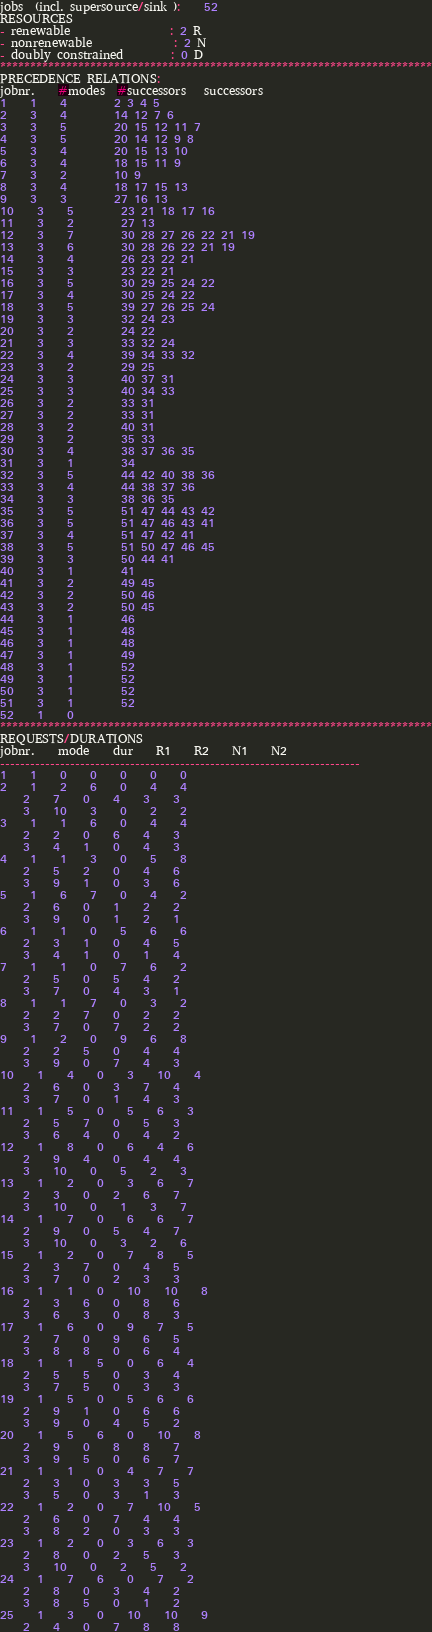Convert code to text. <code><loc_0><loc_0><loc_500><loc_500><_ObjectiveC_>jobs  (incl. supersource/sink ):	52
RESOURCES
- renewable                 : 2 R
- nonrenewable              : 2 N
- doubly constrained        : 0 D
************************************************************************
PRECEDENCE RELATIONS:
jobnr.    #modes  #successors   successors
1	1	4		2 3 4 5 
2	3	4		14 12 7 6 
3	3	5		20 15 12 11 7 
4	3	5		20 14 12 9 8 
5	3	4		20 15 13 10 
6	3	4		18 15 11 9 
7	3	2		10 9 
8	3	4		18 17 15 13 
9	3	3		27 16 13 
10	3	5		23 21 18 17 16 
11	3	2		27 13 
12	3	7		30 28 27 26 22 21 19 
13	3	6		30 28 26 22 21 19 
14	3	4		26 23 22 21 
15	3	3		23 22 21 
16	3	5		30 29 25 24 22 
17	3	4		30 25 24 22 
18	3	5		39 27 26 25 24 
19	3	3		32 24 23 
20	3	2		24 22 
21	3	3		33 32 24 
22	3	4		39 34 33 32 
23	3	2		29 25 
24	3	3		40 37 31 
25	3	3		40 34 33 
26	3	2		33 31 
27	3	2		33 31 
28	3	2		40 31 
29	3	2		35 33 
30	3	4		38 37 36 35 
31	3	1		34 
32	3	5		44 42 40 38 36 
33	3	4		44 38 37 36 
34	3	3		38 36 35 
35	3	5		51 47 44 43 42 
36	3	5		51 47 46 43 41 
37	3	4		51 47 42 41 
38	3	5		51 50 47 46 45 
39	3	3		50 44 41 
40	3	1		41 
41	3	2		49 45 
42	3	2		50 46 
43	3	2		50 45 
44	3	1		46 
45	3	1		48 
46	3	1		48 
47	3	1		49 
48	3	1		52 
49	3	1		52 
50	3	1		52 
51	3	1		52 
52	1	0		
************************************************************************
REQUESTS/DURATIONS
jobnr.	mode	dur	R1	R2	N1	N2	
------------------------------------------------------------------------
1	1	0	0	0	0	0	
2	1	2	6	0	4	4	
	2	7	0	4	3	3	
	3	10	3	0	2	2	
3	1	1	6	0	4	4	
	2	2	0	6	4	3	
	3	4	1	0	4	3	
4	1	1	3	0	5	8	
	2	5	2	0	4	6	
	3	9	1	0	3	6	
5	1	6	7	0	4	2	
	2	6	0	1	2	2	
	3	9	0	1	2	1	
6	1	1	0	5	6	6	
	2	3	1	0	4	5	
	3	4	1	0	1	4	
7	1	1	0	7	6	2	
	2	5	0	5	4	2	
	3	7	0	4	3	1	
8	1	1	7	0	3	2	
	2	2	7	0	2	2	
	3	7	0	7	2	2	
9	1	2	0	9	6	8	
	2	2	5	0	4	4	
	3	9	0	7	4	3	
10	1	4	0	3	10	4	
	2	6	0	3	7	4	
	3	7	0	1	4	3	
11	1	5	0	5	6	3	
	2	5	7	0	5	3	
	3	6	4	0	4	2	
12	1	8	0	6	4	6	
	2	9	4	0	4	4	
	3	10	0	5	2	3	
13	1	2	0	3	6	7	
	2	3	0	2	6	7	
	3	10	0	1	3	7	
14	1	7	0	6	6	7	
	2	9	0	5	4	7	
	3	10	0	3	2	6	
15	1	2	0	7	8	5	
	2	3	7	0	4	5	
	3	7	0	2	3	3	
16	1	1	0	10	10	8	
	2	3	6	0	8	6	
	3	6	3	0	8	3	
17	1	6	0	9	7	5	
	2	7	0	9	6	5	
	3	8	8	0	6	4	
18	1	1	5	0	6	4	
	2	5	5	0	3	4	
	3	7	5	0	3	3	
19	1	5	0	5	6	6	
	2	9	1	0	6	6	
	3	9	0	4	5	2	
20	1	5	6	0	10	8	
	2	9	0	8	8	7	
	3	9	5	0	6	7	
21	1	1	0	4	7	7	
	2	3	0	3	3	5	
	3	5	0	3	1	3	
22	1	2	0	7	10	5	
	2	6	0	7	4	4	
	3	8	2	0	3	3	
23	1	2	0	3	6	3	
	2	8	0	2	5	3	
	3	10	0	2	5	2	
24	1	7	6	0	7	2	
	2	8	0	3	4	2	
	3	8	5	0	1	2	
25	1	3	0	10	10	9	
	2	4	0	7	8	8	</code> 